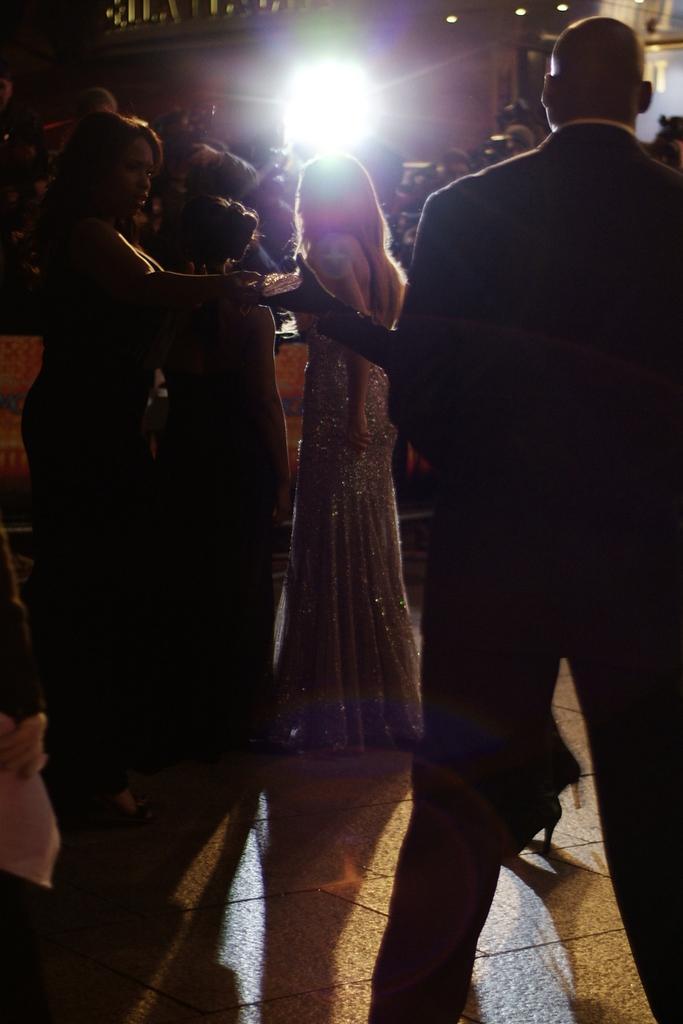Could you give a brief overview of what you see in this image? In the image few people are standing. Behind them there is a light. 